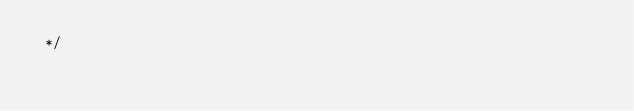Convert code to text. <code><loc_0><loc_0><loc_500><loc_500><_JavaScript_> */</code> 